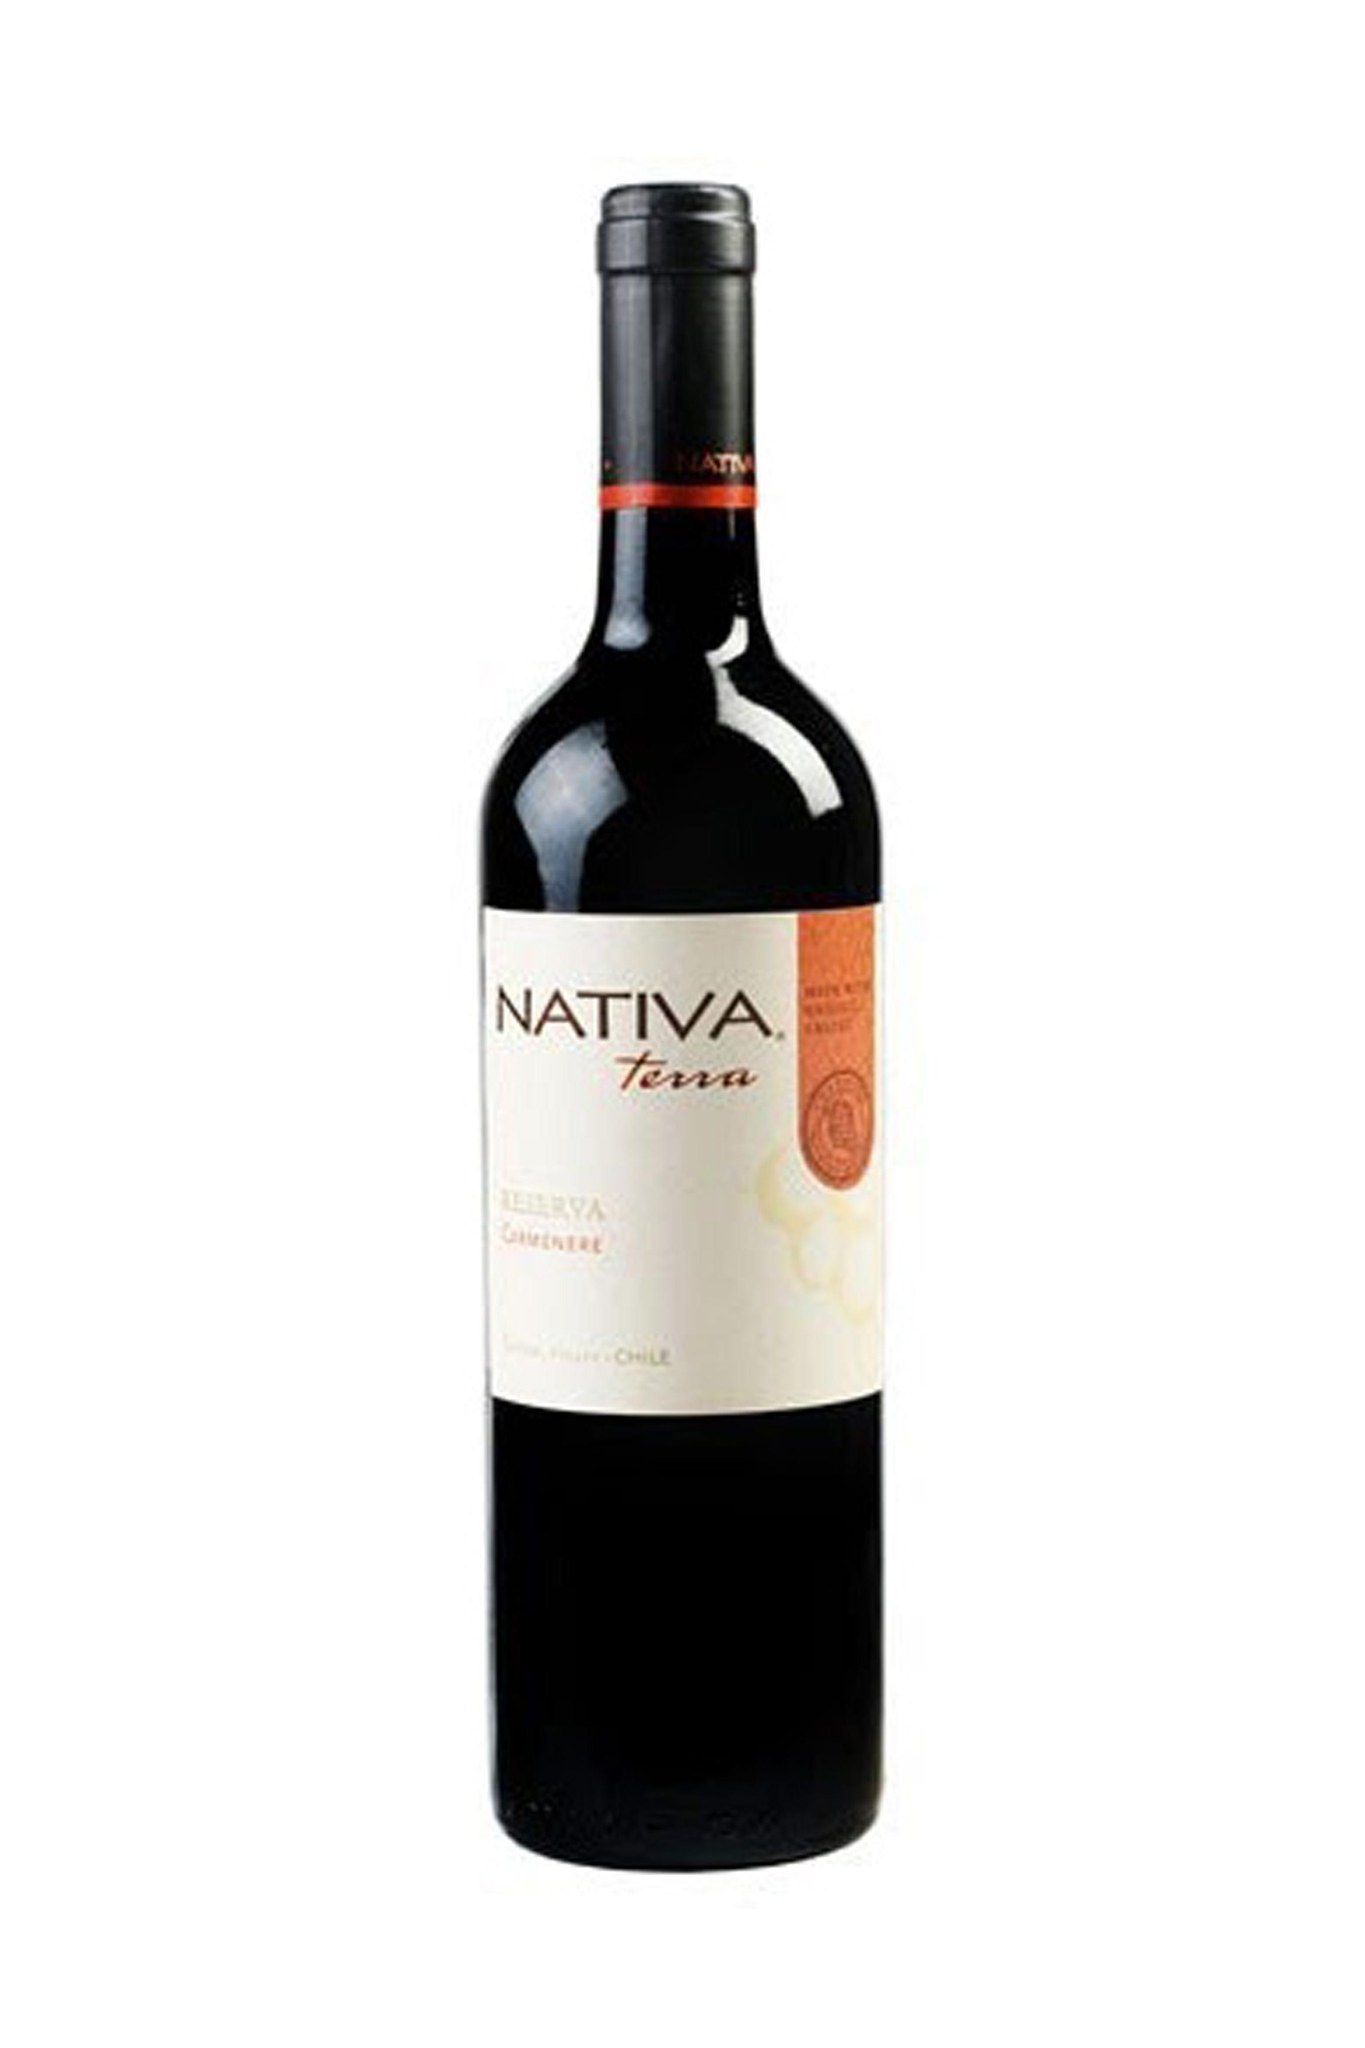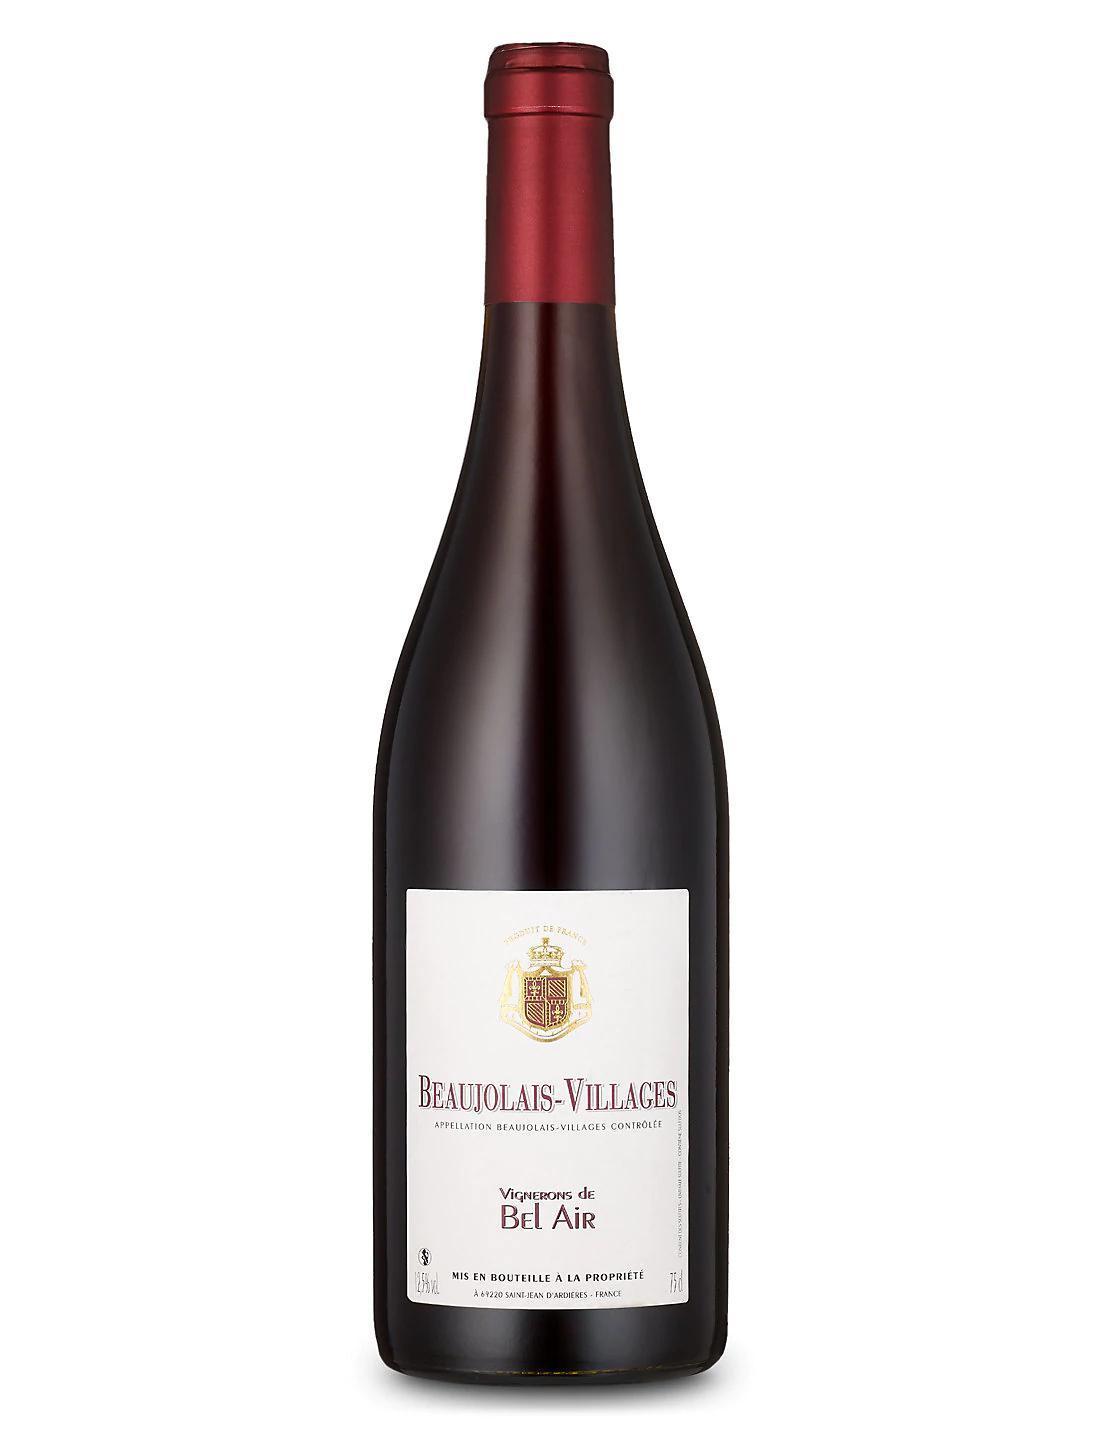The first image is the image on the left, the second image is the image on the right. Examine the images to the left and right. Is the description "Two bottles of wine, one in each image, are sealed closed and have different labels on the body of the bottle." accurate? Answer yes or no. Yes. The first image is the image on the left, the second image is the image on the right. Considering the images on both sides, is "Each image shows a single upright wine bottle, and at least one bottle has a red cap wrap." valid? Answer yes or no. Yes. 